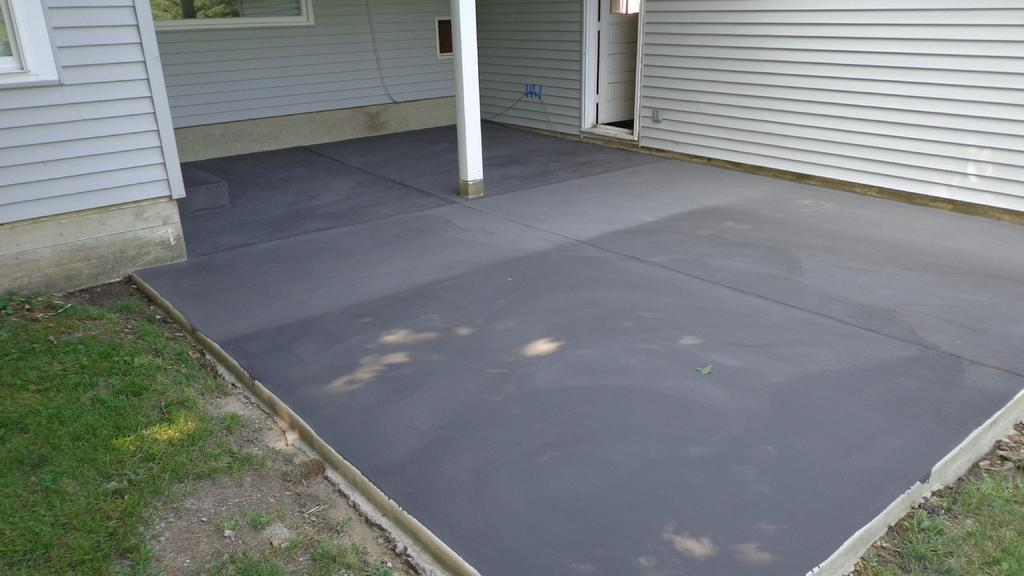What type of surface can be seen in the image? There is grass and tiles visible in the image. What structure is present in the image? There is a pole in the image. What architectural features can be seen in the image? There is a window and a door in the image. What type of walls are present in the image? There are wooden walls in the image. Where is the playground located in the image? There is no playground present in the image. What type of wash is being done in the image? There is no washing activity depicted in the image. 